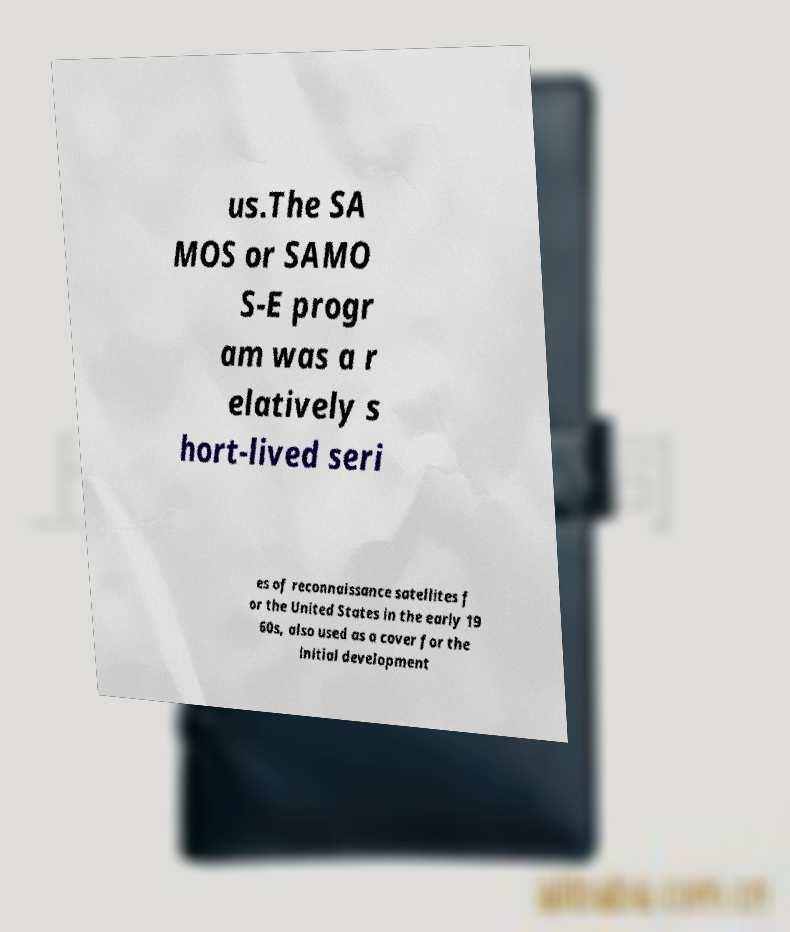Please identify and transcribe the text found in this image. us.The SA MOS or SAMO S-E progr am was a r elatively s hort-lived seri es of reconnaissance satellites f or the United States in the early 19 60s, also used as a cover for the initial development 